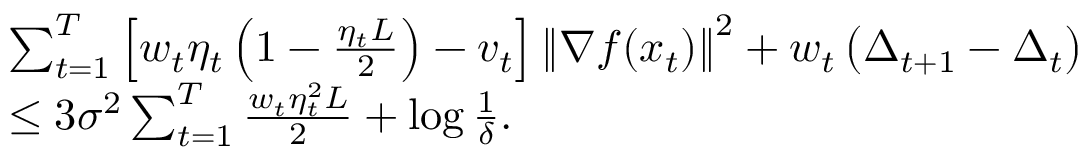Convert formula to latex. <formula><loc_0><loc_0><loc_500><loc_500>\begin{array} { r l } & { \sum _ { t = 1 } ^ { T } \left [ w _ { t } \eta _ { t } \left ( 1 - \frac { \eta _ { t } L } { 2 } \right ) - v _ { t } \right ] \left \| \nabla f ( x _ { t } ) \right \| ^ { 2 } + w _ { t } \left ( \Delta _ { t + 1 } - \Delta _ { t } \right ) } \\ & { \leq 3 \sigma ^ { 2 } \sum _ { t = 1 } ^ { T } \frac { w _ { t } \eta _ { t } ^ { 2 } L } { 2 } + \log \frac { 1 } { \delta } . } \end{array}</formula> 